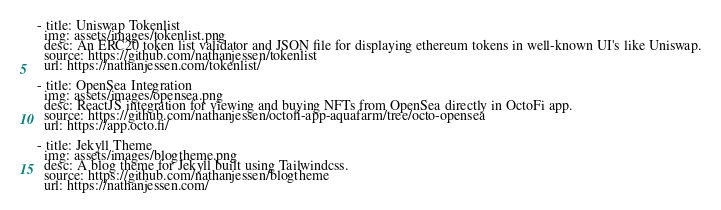<code> <loc_0><loc_0><loc_500><loc_500><_YAML_>- title: Uniswap Tokenlist
  img: assets/images/tokenlist.png
  desc: An ERC20 token list validator and JSON file for displaying ethereum tokens in well-known UI's like Uniswap.
  source: https://github.com/nathanjessen/tokenlist
  url: https://nathanjessen.com/tokenlist/

- title: OpenSea Integration
  img: assets/images/opensea.png
  desc: ReactJS integration for viewing and buying NFTs from OpenSea directly in OctoFi app.
  source: https://github.com/nathanjessen/octofi-app-aquafarm/tree/octo-opensea
  url: https://app.octo.fi/

- title: Jekyll Theme
  img: assets/images/blogtheme.png
  desc: A blog theme for Jekyll built using Tailwindcss.
  source: https://github.com/nathanjessen/blogtheme
  url: https://nathanjessen.com/
</code> 